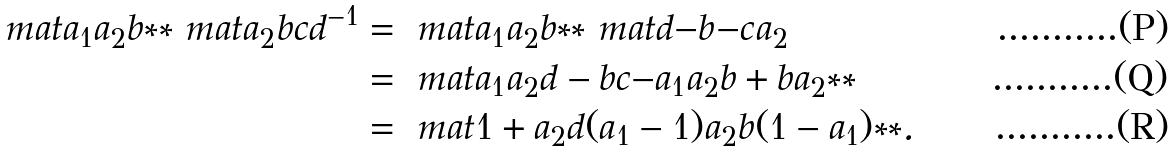<formula> <loc_0><loc_0><loc_500><loc_500>\ m a t { a _ { 1 } a _ { 2 } } { b } { * } { * } \ m a t { a _ { 2 } } { b } { c } { d } ^ { - 1 } & = \ m a t { a _ { 1 } a _ { 2 } } { b } { * } { * } \ m a t { d } { - b } { - c } { a _ { 2 } } \\ & = \ m a t { a _ { 1 } a _ { 2 } d - b c } { - a _ { 1 } a _ { 2 } b + b a _ { 2 } } { * } { * } \\ & = \ m a t { 1 + a _ { 2 } d ( a _ { 1 } - 1 ) } { a _ { 2 } b ( 1 - a _ { 1 } ) } { * } { * } .</formula> 